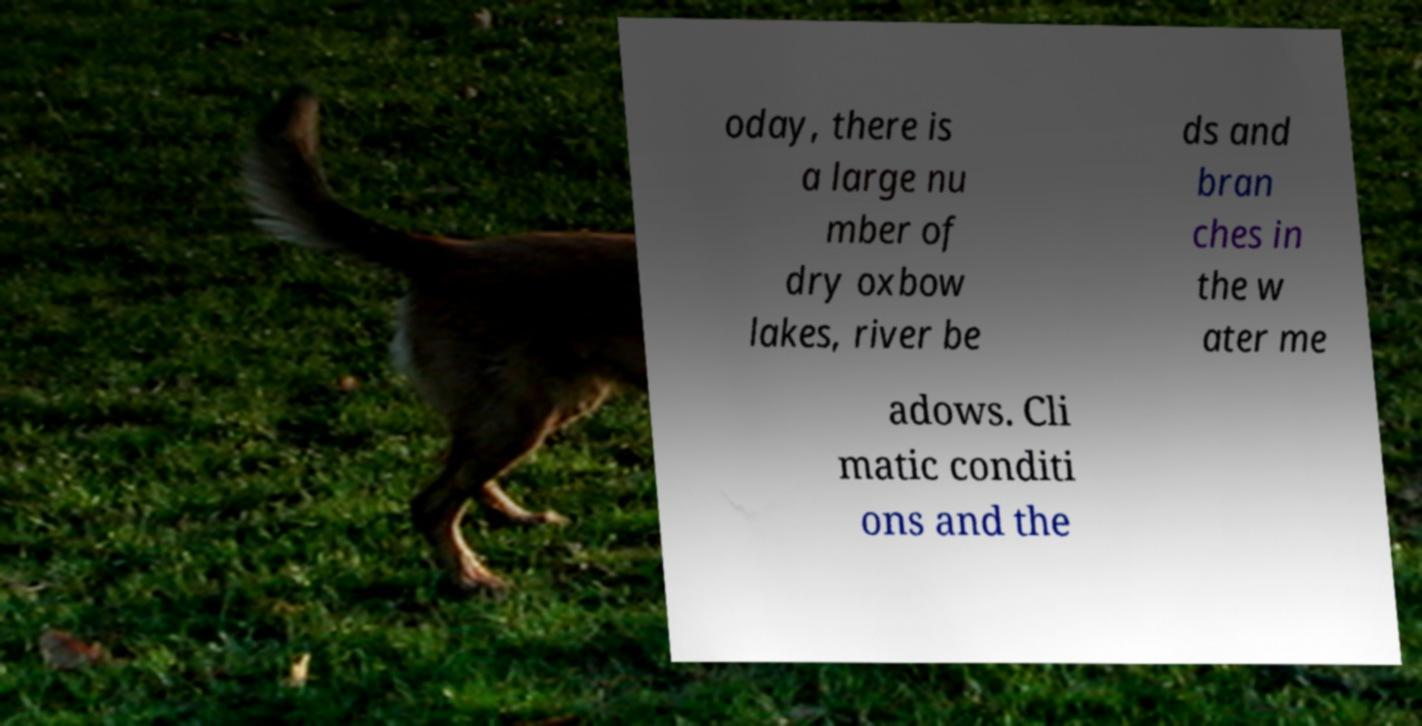I need the written content from this picture converted into text. Can you do that? oday, there is a large nu mber of dry oxbow lakes, river be ds and bran ches in the w ater me adows. Cli matic conditi ons and the 